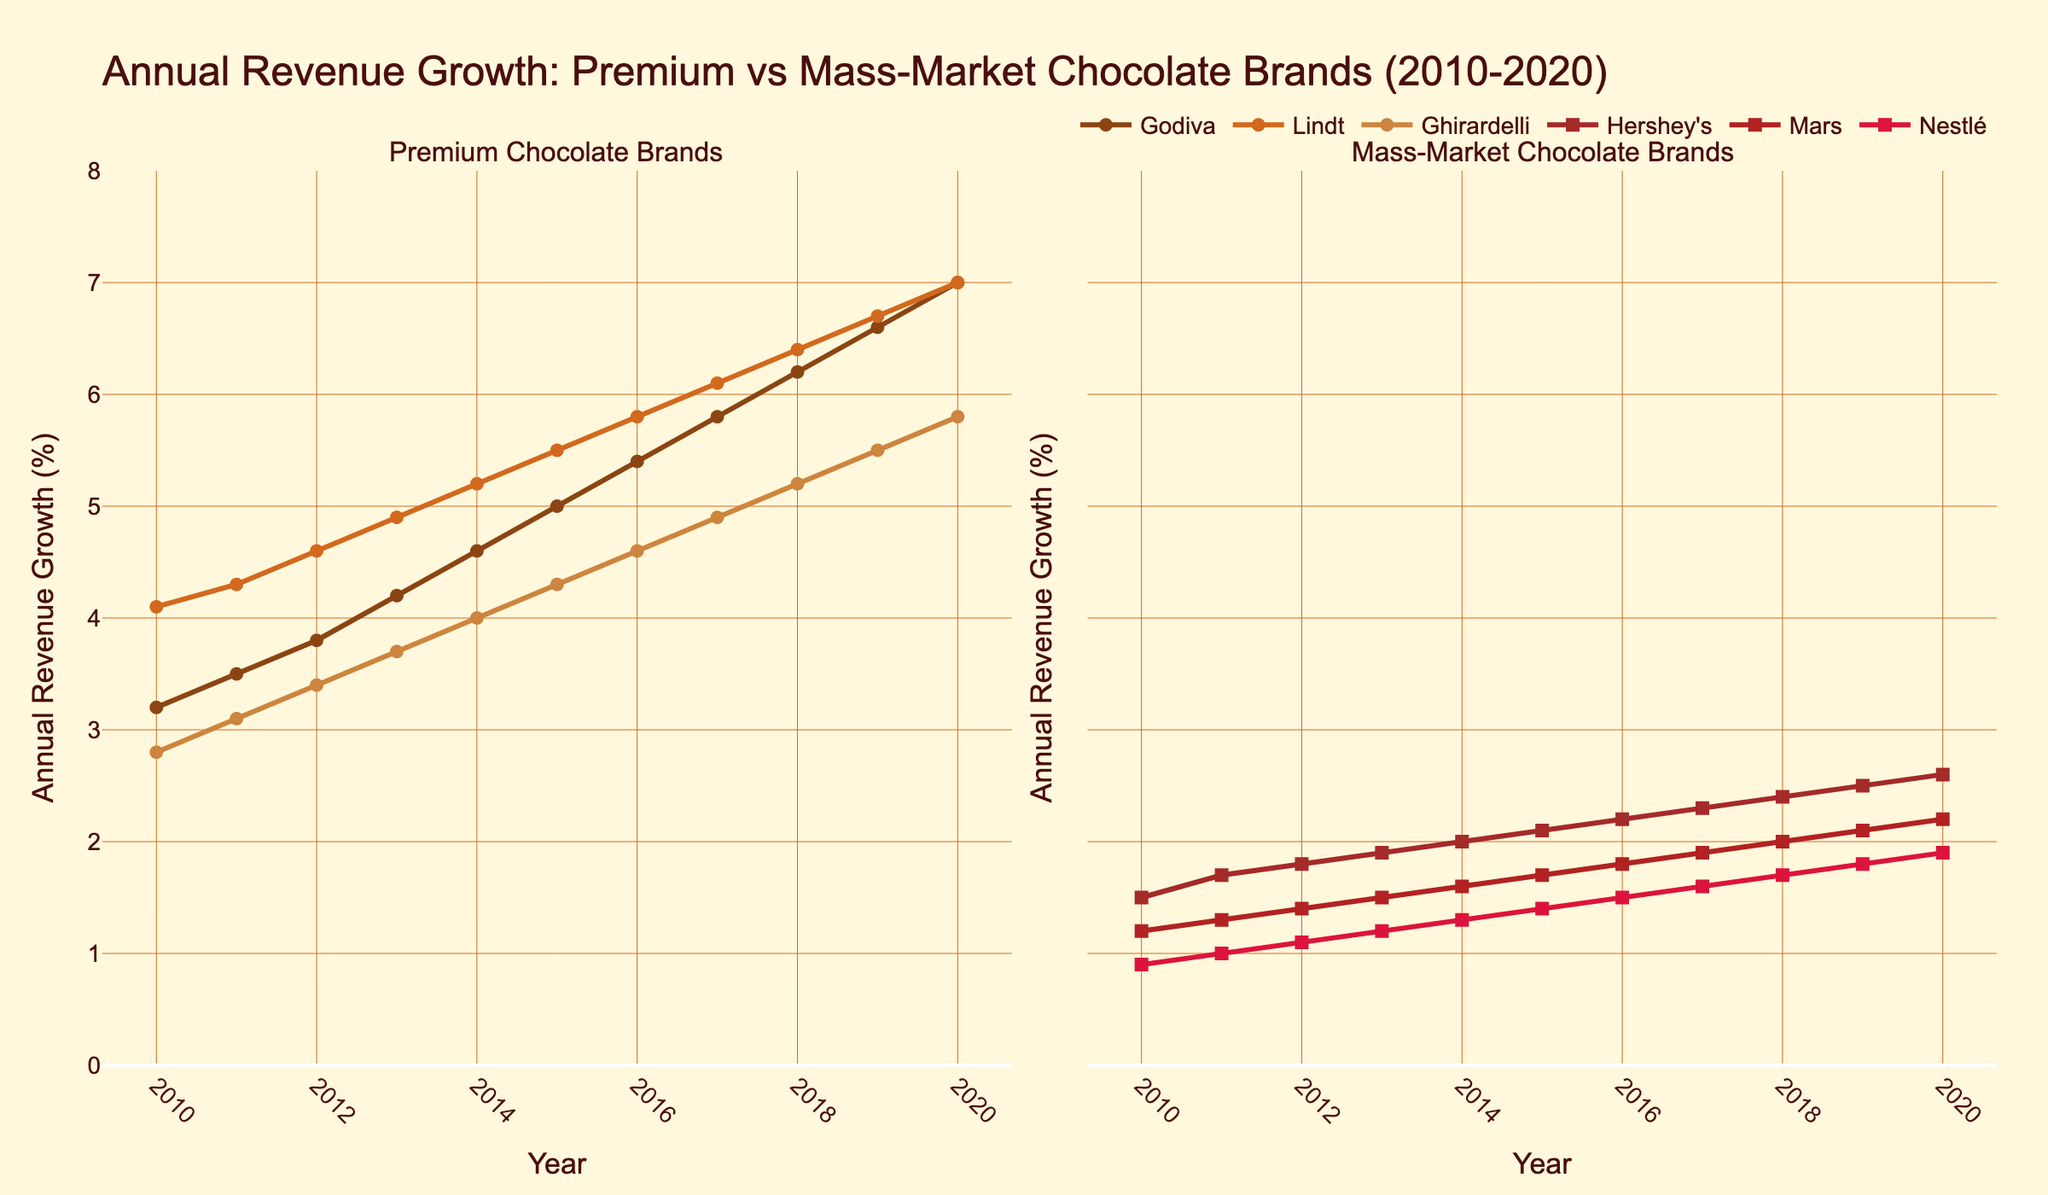Which brand showed the highest annual revenue growth in 2020 among premium chocolate brands? The subplot for premium chocolate brands shows lines for Godiva, Lindt, and Ghirardelli. In 2020, Godiva's line (dark brown) reaches the highest point compared to Lindt and Ghirardelli
Answer: Godiva Between 2010 and 2020, which mass-market brand experienced the most consistent growth? Checking the subplot for mass-market chocolate brands, we observe that Hershey's line exhibits steady growth without significant fluctuations, compared to Mars and Nestlé
Answer: Hershey's What is the difference in annual revenue growth between Lindt and Hershey's in 2020? In 2020, the annual revenue growth for Lindt is 7.0% and for Hershey's is 2.6%. The difference is 7.0% - 2.6%
Answer: 4.4% Among all the brands, which one had the lowest growth in 2014? By examining both subplots, the lowest point in 2014 is for Nestlé with a growth of 1.3%
Answer: Nestlé How did Ghirardelli's growth compare to Mars' growth in 2015? In 2015, Ghirardelli had a growth of 4.3%, and Mars had a growth of 1.7%. Ghirardelli's growth was significantly higher
Answer: Ghirardelli's growth was higher Calculate the average annual revenue growth for the premium brands in 2019 To find the average, sum Godiva's (6.6%), Lindt's (6.7%), and Ghirardelli's (5.5%) growth rates for 2019 and divide by 3: (6.6 + 6.7 + 5.5) / 3 = 6.27%
Answer: 6.27% Compare the trend of revenue growth between premium and mass-market brands from 2016 to 2018. What do you observe? From 2016 to 2018, the premium brands (Godiva, Lindt, Ghirardelli) show a consistently increasing trend. In contrast, mass-market brands also show growth but at a slower and less consistent rate
Answer: Premium brands grew faster and more consistently What is the growth difference between the highest and the lowest-performing mass-market brand in 2017? In 2017, Hershey's had a growth of 2.3% and Nestlé had a growth of 1.6%. The difference is 2.3% - 1.6%
Answer: 0.7% Which brand had the steepest growth increase between 2012 and 2013? Looking at the slopes of the lines between the years 2012 and 2013, Lindt shows the steepest increase going from 4.6% to 4.9%
Answer: Lindt 